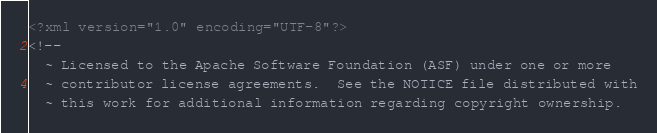Convert code to text. <code><loc_0><loc_0><loc_500><loc_500><_XML_><?xml version="1.0" encoding="UTF-8"?>
<!--
  ~ Licensed to the Apache Software Foundation (ASF) under one or more
  ~ contributor license agreements.  See the NOTICE file distributed with
  ~ this work for additional information regarding copyright ownership.</code> 